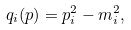Convert formula to latex. <formula><loc_0><loc_0><loc_500><loc_500>q _ { i } ( p ) = p _ { i } ^ { 2 } - m _ { i } ^ { 2 } ,</formula> 